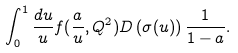<formula> <loc_0><loc_0><loc_500><loc_500>\int _ { 0 } ^ { 1 } \frac { d u } { u } f ( \frac { a } { u } , Q ^ { 2 } ) D \left ( \sigma ( u ) \right ) \frac { 1 } { 1 - a } .</formula> 